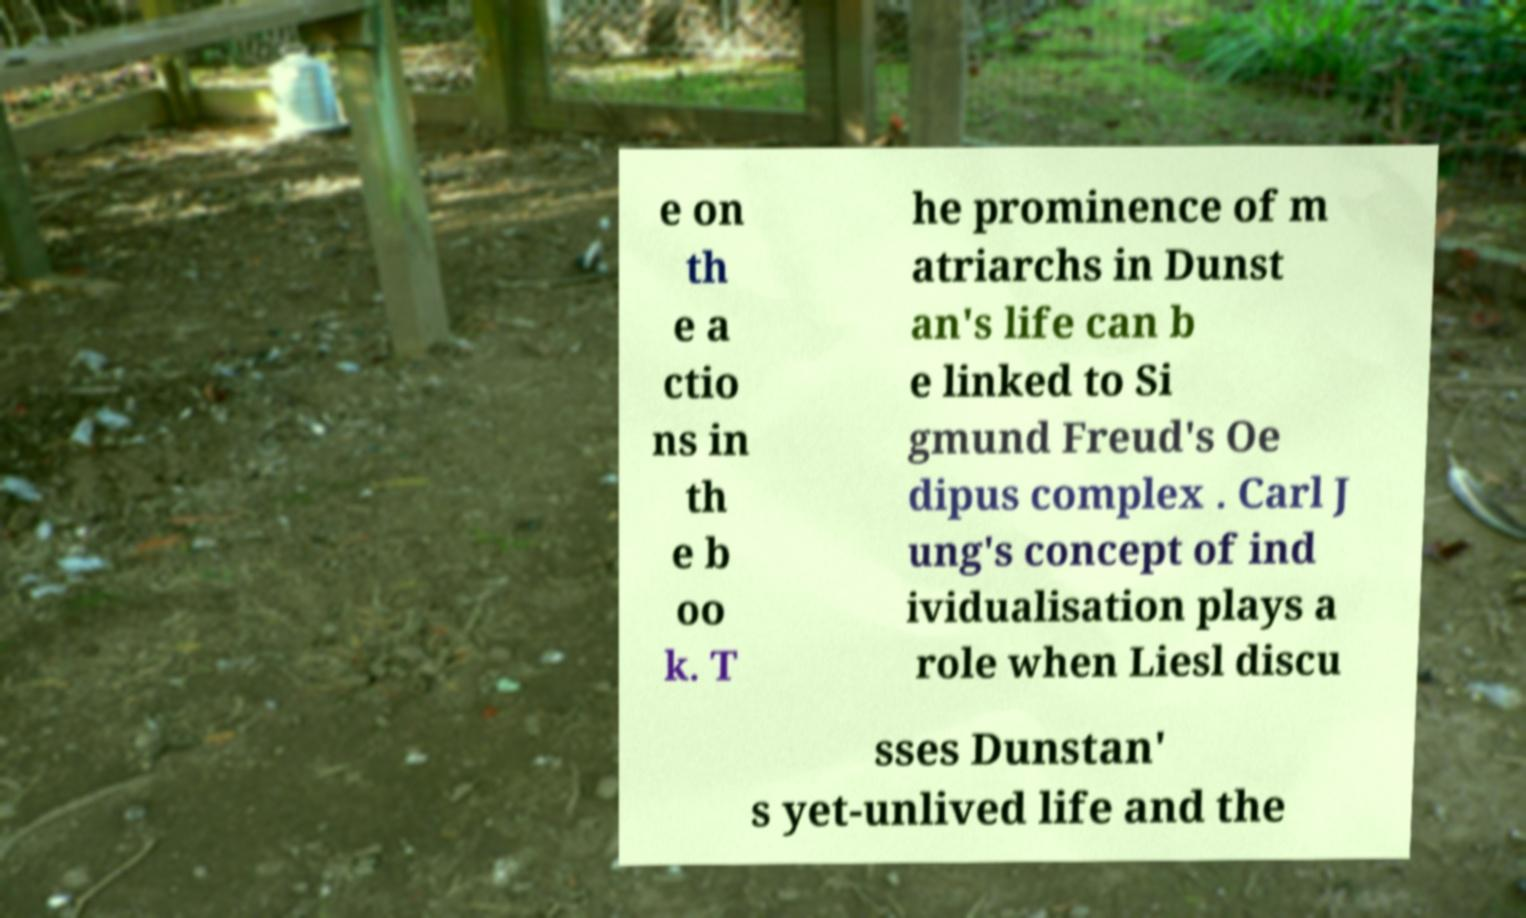Please read and relay the text visible in this image. What does it say? e on th e a ctio ns in th e b oo k. T he prominence of m atriarchs in Dunst an's life can b e linked to Si gmund Freud's Oe dipus complex . Carl J ung's concept of ind ividualisation plays a role when Liesl discu sses Dunstan' s yet-unlived life and the 